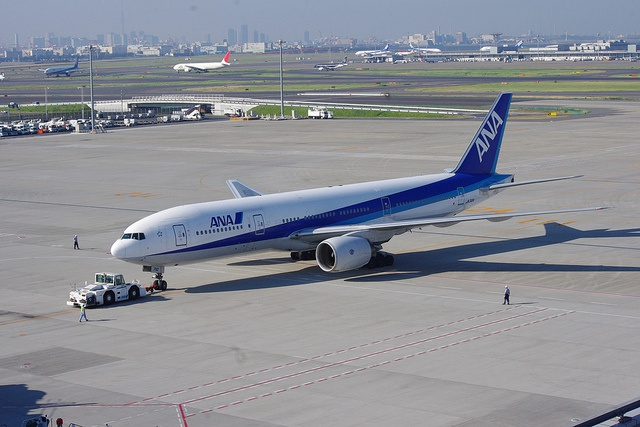Describe the objects in this image and their specific colors. I can see airplane in darkgray, navy, and gray tones, truck in darkgray, black, lightgray, and gray tones, airplane in darkgray, white, gray, and salmon tones, airplane in darkgray, gray, darkblue, and blue tones, and airplane in darkgray, gray, and lightgray tones in this image. 